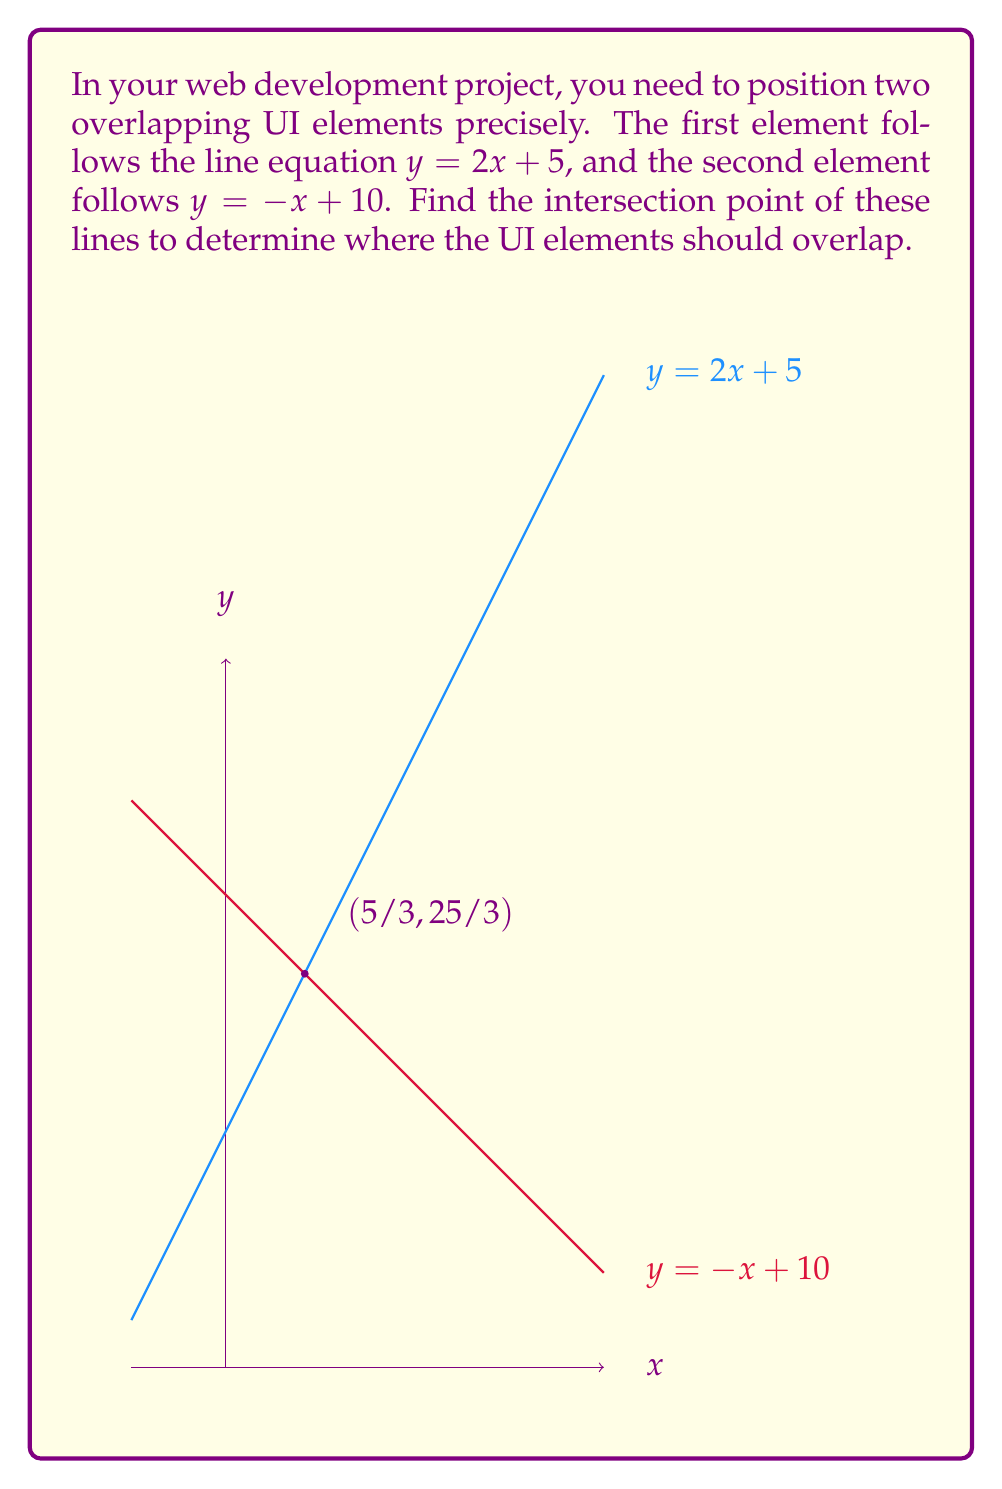What is the answer to this math problem? To find the intersection point of two lines, we need to solve the system of equations formed by the two line equations. Let's approach this step-by-step:

1) We have two equations:
   Line 1: $y = 2x + 5$
   Line 2: $y = -x + 10$

2) At the intersection point, the y-values will be equal. So we can set the right sides of these equations equal to each other:

   $2x + 5 = -x + 10$

3) Now we can solve this equation for x:
   $2x + 5 = -x + 10$
   $3x = 5$
   $x = 5/3$

4) To find y, we can substitute this x-value into either of the original equations. Let's use the first one:

   $y = 2(5/3) + 5$
   $y = 10/3 + 5$
   $y = 10/3 + 15/3$
   $y = 25/3$

5) Therefore, the intersection point is $(5/3, 25/3)$.

In the context of UI design, this means that the two elements should overlap at the point (5/3, 25/3) in your coordinate system. Depending on your specific implementation, you may need to convert these fractional values to pixels or other units used in your layout.
Answer: The intersection point is $(5/3, 25/3)$. 